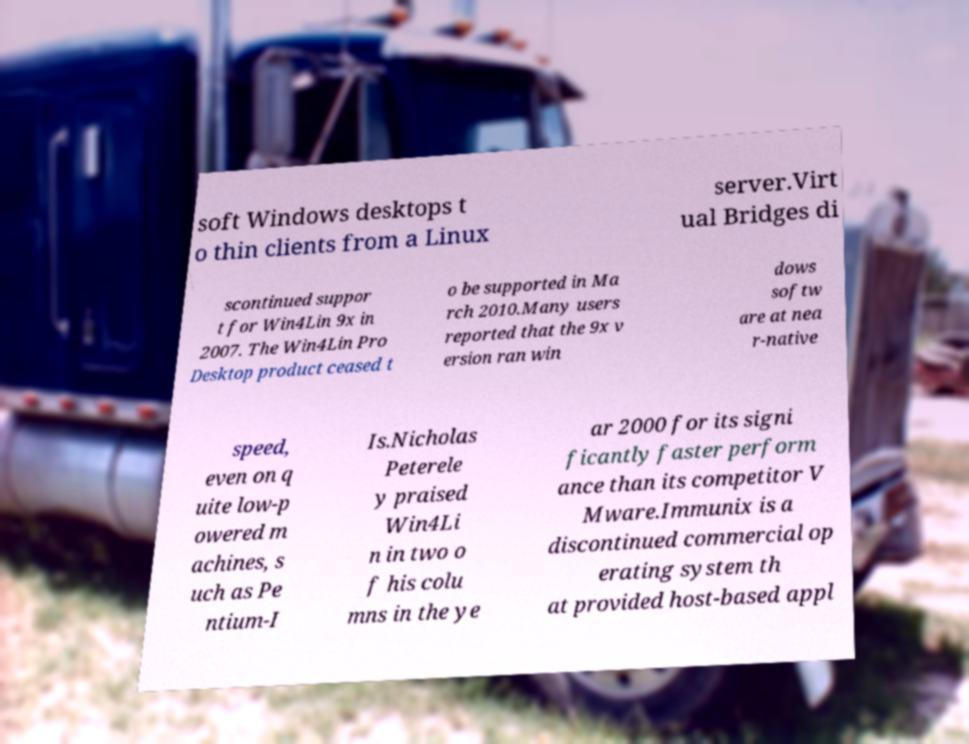There's text embedded in this image that I need extracted. Can you transcribe it verbatim? soft Windows desktops t o thin clients from a Linux server.Virt ual Bridges di scontinued suppor t for Win4Lin 9x in 2007. The Win4Lin Pro Desktop product ceased t o be supported in Ma rch 2010.Many users reported that the 9x v ersion ran win dows softw are at nea r-native speed, even on q uite low-p owered m achines, s uch as Pe ntium-I Is.Nicholas Peterele y praised Win4Li n in two o f his colu mns in the ye ar 2000 for its signi ficantly faster perform ance than its competitor V Mware.Immunix is a discontinued commercial op erating system th at provided host-based appl 